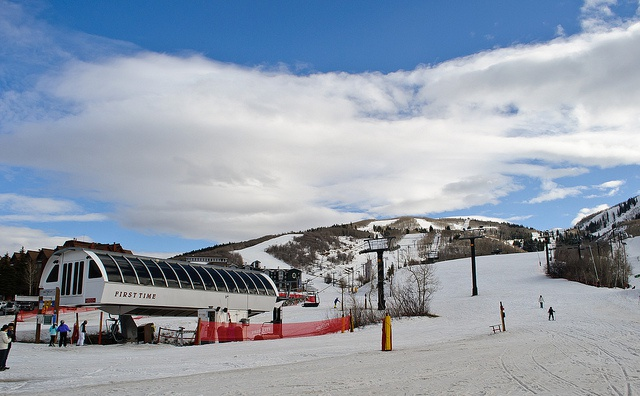Describe the objects in this image and their specific colors. I can see people in gray, black, and darkgray tones, people in gray, black, darkblue, navy, and darkgray tones, people in gray, black, and darkgray tones, people in gray, black, darkgray, and maroon tones, and people in gray, black, and teal tones in this image. 